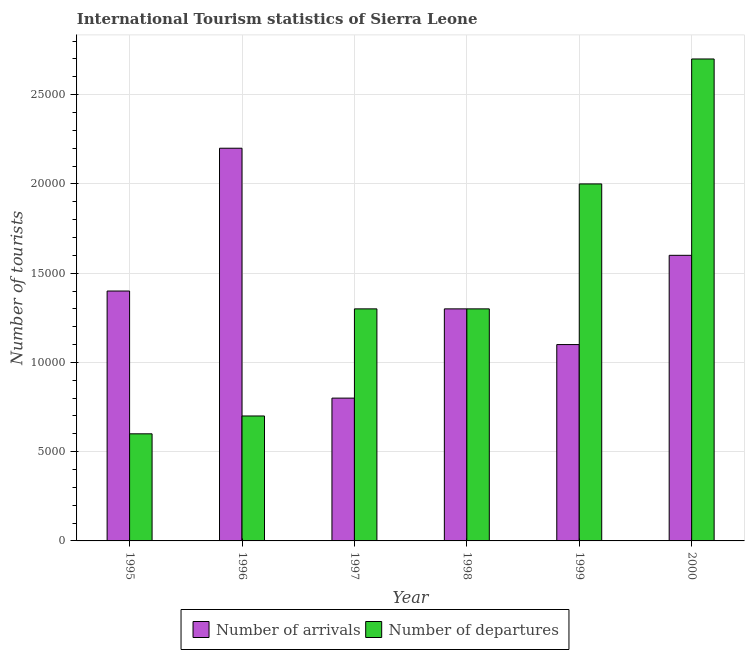How many bars are there on the 1st tick from the left?
Your answer should be compact. 2. What is the label of the 1st group of bars from the left?
Provide a succinct answer. 1995. In how many cases, is the number of bars for a given year not equal to the number of legend labels?
Offer a terse response. 0. What is the number of tourist arrivals in 1997?
Your response must be concise. 8000. Across all years, what is the maximum number of tourist arrivals?
Give a very brief answer. 2.20e+04. Across all years, what is the minimum number of tourist arrivals?
Provide a short and direct response. 8000. In which year was the number of tourist departures maximum?
Your answer should be compact. 2000. In which year was the number of tourist arrivals minimum?
Your response must be concise. 1997. What is the total number of tourist arrivals in the graph?
Ensure brevity in your answer.  8.40e+04. What is the difference between the number of tourist arrivals in 1995 and that in 2000?
Provide a short and direct response. -2000. What is the difference between the number of tourist arrivals in 1997 and the number of tourist departures in 1996?
Provide a short and direct response. -1.40e+04. What is the average number of tourist arrivals per year?
Give a very brief answer. 1.40e+04. In the year 1995, what is the difference between the number of tourist departures and number of tourist arrivals?
Your answer should be compact. 0. In how many years, is the number of tourist arrivals greater than 21000?
Your answer should be compact. 1. What is the ratio of the number of tourist departures in 1995 to that in 1998?
Provide a succinct answer. 0.46. Is the number of tourist departures in 1996 less than that in 1999?
Offer a very short reply. Yes. Is the difference between the number of tourist departures in 1997 and 2000 greater than the difference between the number of tourist arrivals in 1997 and 2000?
Provide a succinct answer. No. What is the difference between the highest and the second highest number of tourist departures?
Give a very brief answer. 7000. What is the difference between the highest and the lowest number of tourist arrivals?
Make the answer very short. 1.40e+04. In how many years, is the number of tourist arrivals greater than the average number of tourist arrivals taken over all years?
Provide a succinct answer. 2. What does the 1st bar from the left in 1996 represents?
Offer a very short reply. Number of arrivals. What does the 1st bar from the right in 1998 represents?
Keep it short and to the point. Number of departures. How many bars are there?
Offer a terse response. 12. Are all the bars in the graph horizontal?
Your answer should be compact. No. Are the values on the major ticks of Y-axis written in scientific E-notation?
Offer a terse response. No. How are the legend labels stacked?
Ensure brevity in your answer.  Horizontal. What is the title of the graph?
Give a very brief answer. International Tourism statistics of Sierra Leone. What is the label or title of the Y-axis?
Provide a short and direct response. Number of tourists. What is the Number of tourists of Number of arrivals in 1995?
Your answer should be compact. 1.40e+04. What is the Number of tourists in Number of departures in 1995?
Keep it short and to the point. 6000. What is the Number of tourists in Number of arrivals in 1996?
Offer a terse response. 2.20e+04. What is the Number of tourists of Number of departures in 1996?
Provide a short and direct response. 7000. What is the Number of tourists of Number of arrivals in 1997?
Keep it short and to the point. 8000. What is the Number of tourists in Number of departures in 1997?
Offer a very short reply. 1.30e+04. What is the Number of tourists of Number of arrivals in 1998?
Give a very brief answer. 1.30e+04. What is the Number of tourists in Number of departures in 1998?
Make the answer very short. 1.30e+04. What is the Number of tourists in Number of arrivals in 1999?
Give a very brief answer. 1.10e+04. What is the Number of tourists of Number of arrivals in 2000?
Provide a succinct answer. 1.60e+04. What is the Number of tourists of Number of departures in 2000?
Ensure brevity in your answer.  2.70e+04. Across all years, what is the maximum Number of tourists of Number of arrivals?
Keep it short and to the point. 2.20e+04. Across all years, what is the maximum Number of tourists in Number of departures?
Your response must be concise. 2.70e+04. Across all years, what is the minimum Number of tourists of Number of arrivals?
Provide a succinct answer. 8000. Across all years, what is the minimum Number of tourists in Number of departures?
Make the answer very short. 6000. What is the total Number of tourists of Number of arrivals in the graph?
Your response must be concise. 8.40e+04. What is the total Number of tourists of Number of departures in the graph?
Your answer should be very brief. 8.60e+04. What is the difference between the Number of tourists of Number of arrivals in 1995 and that in 1996?
Provide a short and direct response. -8000. What is the difference between the Number of tourists of Number of departures in 1995 and that in 1996?
Give a very brief answer. -1000. What is the difference between the Number of tourists of Number of arrivals in 1995 and that in 1997?
Ensure brevity in your answer.  6000. What is the difference between the Number of tourists of Number of departures in 1995 and that in 1997?
Provide a short and direct response. -7000. What is the difference between the Number of tourists of Number of arrivals in 1995 and that in 1998?
Provide a short and direct response. 1000. What is the difference between the Number of tourists in Number of departures in 1995 and that in 1998?
Give a very brief answer. -7000. What is the difference between the Number of tourists in Number of arrivals in 1995 and that in 1999?
Ensure brevity in your answer.  3000. What is the difference between the Number of tourists of Number of departures in 1995 and that in 1999?
Your answer should be compact. -1.40e+04. What is the difference between the Number of tourists in Number of arrivals in 1995 and that in 2000?
Your answer should be compact. -2000. What is the difference between the Number of tourists of Number of departures in 1995 and that in 2000?
Make the answer very short. -2.10e+04. What is the difference between the Number of tourists in Number of arrivals in 1996 and that in 1997?
Provide a short and direct response. 1.40e+04. What is the difference between the Number of tourists of Number of departures in 1996 and that in 1997?
Ensure brevity in your answer.  -6000. What is the difference between the Number of tourists of Number of arrivals in 1996 and that in 1998?
Make the answer very short. 9000. What is the difference between the Number of tourists in Number of departures in 1996 and that in 1998?
Provide a succinct answer. -6000. What is the difference between the Number of tourists of Number of arrivals in 1996 and that in 1999?
Keep it short and to the point. 1.10e+04. What is the difference between the Number of tourists of Number of departures in 1996 and that in 1999?
Offer a terse response. -1.30e+04. What is the difference between the Number of tourists in Number of arrivals in 1996 and that in 2000?
Provide a short and direct response. 6000. What is the difference between the Number of tourists in Number of departures in 1996 and that in 2000?
Keep it short and to the point. -2.00e+04. What is the difference between the Number of tourists of Number of arrivals in 1997 and that in 1998?
Provide a succinct answer. -5000. What is the difference between the Number of tourists of Number of arrivals in 1997 and that in 1999?
Make the answer very short. -3000. What is the difference between the Number of tourists of Number of departures in 1997 and that in 1999?
Your answer should be very brief. -7000. What is the difference between the Number of tourists in Number of arrivals in 1997 and that in 2000?
Offer a terse response. -8000. What is the difference between the Number of tourists of Number of departures in 1997 and that in 2000?
Offer a very short reply. -1.40e+04. What is the difference between the Number of tourists of Number of departures in 1998 and that in 1999?
Your response must be concise. -7000. What is the difference between the Number of tourists in Number of arrivals in 1998 and that in 2000?
Keep it short and to the point. -3000. What is the difference between the Number of tourists in Number of departures in 1998 and that in 2000?
Your response must be concise. -1.40e+04. What is the difference between the Number of tourists in Number of arrivals in 1999 and that in 2000?
Provide a succinct answer. -5000. What is the difference between the Number of tourists in Number of departures in 1999 and that in 2000?
Offer a terse response. -7000. What is the difference between the Number of tourists in Number of arrivals in 1995 and the Number of tourists in Number of departures in 1996?
Make the answer very short. 7000. What is the difference between the Number of tourists of Number of arrivals in 1995 and the Number of tourists of Number of departures in 1997?
Ensure brevity in your answer.  1000. What is the difference between the Number of tourists of Number of arrivals in 1995 and the Number of tourists of Number of departures in 1998?
Your answer should be very brief. 1000. What is the difference between the Number of tourists in Number of arrivals in 1995 and the Number of tourists in Number of departures in 1999?
Give a very brief answer. -6000. What is the difference between the Number of tourists of Number of arrivals in 1995 and the Number of tourists of Number of departures in 2000?
Provide a short and direct response. -1.30e+04. What is the difference between the Number of tourists in Number of arrivals in 1996 and the Number of tourists in Number of departures in 1997?
Provide a succinct answer. 9000. What is the difference between the Number of tourists in Number of arrivals in 1996 and the Number of tourists in Number of departures in 1998?
Make the answer very short. 9000. What is the difference between the Number of tourists of Number of arrivals in 1996 and the Number of tourists of Number of departures in 2000?
Your answer should be very brief. -5000. What is the difference between the Number of tourists in Number of arrivals in 1997 and the Number of tourists in Number of departures in 1998?
Make the answer very short. -5000. What is the difference between the Number of tourists in Number of arrivals in 1997 and the Number of tourists in Number of departures in 1999?
Provide a short and direct response. -1.20e+04. What is the difference between the Number of tourists of Number of arrivals in 1997 and the Number of tourists of Number of departures in 2000?
Offer a very short reply. -1.90e+04. What is the difference between the Number of tourists of Number of arrivals in 1998 and the Number of tourists of Number of departures in 1999?
Your answer should be compact. -7000. What is the difference between the Number of tourists in Number of arrivals in 1998 and the Number of tourists in Number of departures in 2000?
Your answer should be compact. -1.40e+04. What is the difference between the Number of tourists of Number of arrivals in 1999 and the Number of tourists of Number of departures in 2000?
Your answer should be compact. -1.60e+04. What is the average Number of tourists in Number of arrivals per year?
Keep it short and to the point. 1.40e+04. What is the average Number of tourists in Number of departures per year?
Give a very brief answer. 1.43e+04. In the year 1995, what is the difference between the Number of tourists of Number of arrivals and Number of tourists of Number of departures?
Offer a very short reply. 8000. In the year 1996, what is the difference between the Number of tourists in Number of arrivals and Number of tourists in Number of departures?
Your answer should be very brief. 1.50e+04. In the year 1997, what is the difference between the Number of tourists in Number of arrivals and Number of tourists in Number of departures?
Your answer should be compact. -5000. In the year 1999, what is the difference between the Number of tourists in Number of arrivals and Number of tourists in Number of departures?
Give a very brief answer. -9000. In the year 2000, what is the difference between the Number of tourists of Number of arrivals and Number of tourists of Number of departures?
Provide a succinct answer. -1.10e+04. What is the ratio of the Number of tourists in Number of arrivals in 1995 to that in 1996?
Offer a terse response. 0.64. What is the ratio of the Number of tourists in Number of arrivals in 1995 to that in 1997?
Keep it short and to the point. 1.75. What is the ratio of the Number of tourists in Number of departures in 1995 to that in 1997?
Offer a very short reply. 0.46. What is the ratio of the Number of tourists of Number of departures in 1995 to that in 1998?
Provide a succinct answer. 0.46. What is the ratio of the Number of tourists of Number of arrivals in 1995 to that in 1999?
Ensure brevity in your answer.  1.27. What is the ratio of the Number of tourists of Number of departures in 1995 to that in 1999?
Offer a very short reply. 0.3. What is the ratio of the Number of tourists of Number of arrivals in 1995 to that in 2000?
Provide a succinct answer. 0.88. What is the ratio of the Number of tourists in Number of departures in 1995 to that in 2000?
Make the answer very short. 0.22. What is the ratio of the Number of tourists in Number of arrivals in 1996 to that in 1997?
Your answer should be very brief. 2.75. What is the ratio of the Number of tourists of Number of departures in 1996 to that in 1997?
Keep it short and to the point. 0.54. What is the ratio of the Number of tourists of Number of arrivals in 1996 to that in 1998?
Your answer should be very brief. 1.69. What is the ratio of the Number of tourists in Number of departures in 1996 to that in 1998?
Ensure brevity in your answer.  0.54. What is the ratio of the Number of tourists of Number of arrivals in 1996 to that in 1999?
Make the answer very short. 2. What is the ratio of the Number of tourists of Number of arrivals in 1996 to that in 2000?
Keep it short and to the point. 1.38. What is the ratio of the Number of tourists in Number of departures in 1996 to that in 2000?
Offer a terse response. 0.26. What is the ratio of the Number of tourists in Number of arrivals in 1997 to that in 1998?
Your answer should be very brief. 0.62. What is the ratio of the Number of tourists in Number of arrivals in 1997 to that in 1999?
Ensure brevity in your answer.  0.73. What is the ratio of the Number of tourists in Number of departures in 1997 to that in 1999?
Offer a very short reply. 0.65. What is the ratio of the Number of tourists in Number of arrivals in 1997 to that in 2000?
Make the answer very short. 0.5. What is the ratio of the Number of tourists in Number of departures in 1997 to that in 2000?
Your response must be concise. 0.48. What is the ratio of the Number of tourists of Number of arrivals in 1998 to that in 1999?
Make the answer very short. 1.18. What is the ratio of the Number of tourists of Number of departures in 1998 to that in 1999?
Offer a very short reply. 0.65. What is the ratio of the Number of tourists of Number of arrivals in 1998 to that in 2000?
Keep it short and to the point. 0.81. What is the ratio of the Number of tourists of Number of departures in 1998 to that in 2000?
Your answer should be very brief. 0.48. What is the ratio of the Number of tourists of Number of arrivals in 1999 to that in 2000?
Make the answer very short. 0.69. What is the ratio of the Number of tourists in Number of departures in 1999 to that in 2000?
Your answer should be compact. 0.74. What is the difference between the highest and the second highest Number of tourists of Number of arrivals?
Offer a terse response. 6000. What is the difference between the highest and the second highest Number of tourists in Number of departures?
Keep it short and to the point. 7000. What is the difference between the highest and the lowest Number of tourists in Number of arrivals?
Make the answer very short. 1.40e+04. What is the difference between the highest and the lowest Number of tourists in Number of departures?
Your answer should be compact. 2.10e+04. 